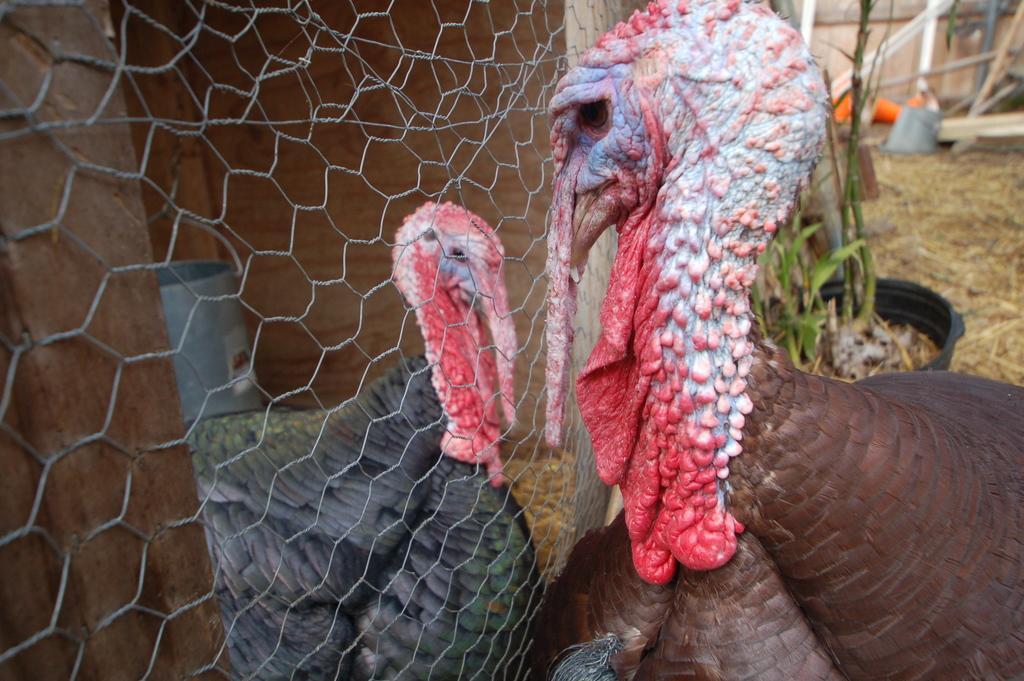How would you summarize this image in a sentence or two? In this picture we can see the turkey birds. In between the birds there is a fence and wooden poles. Behind the birds there is a plant in the pot and some blurred objects. 